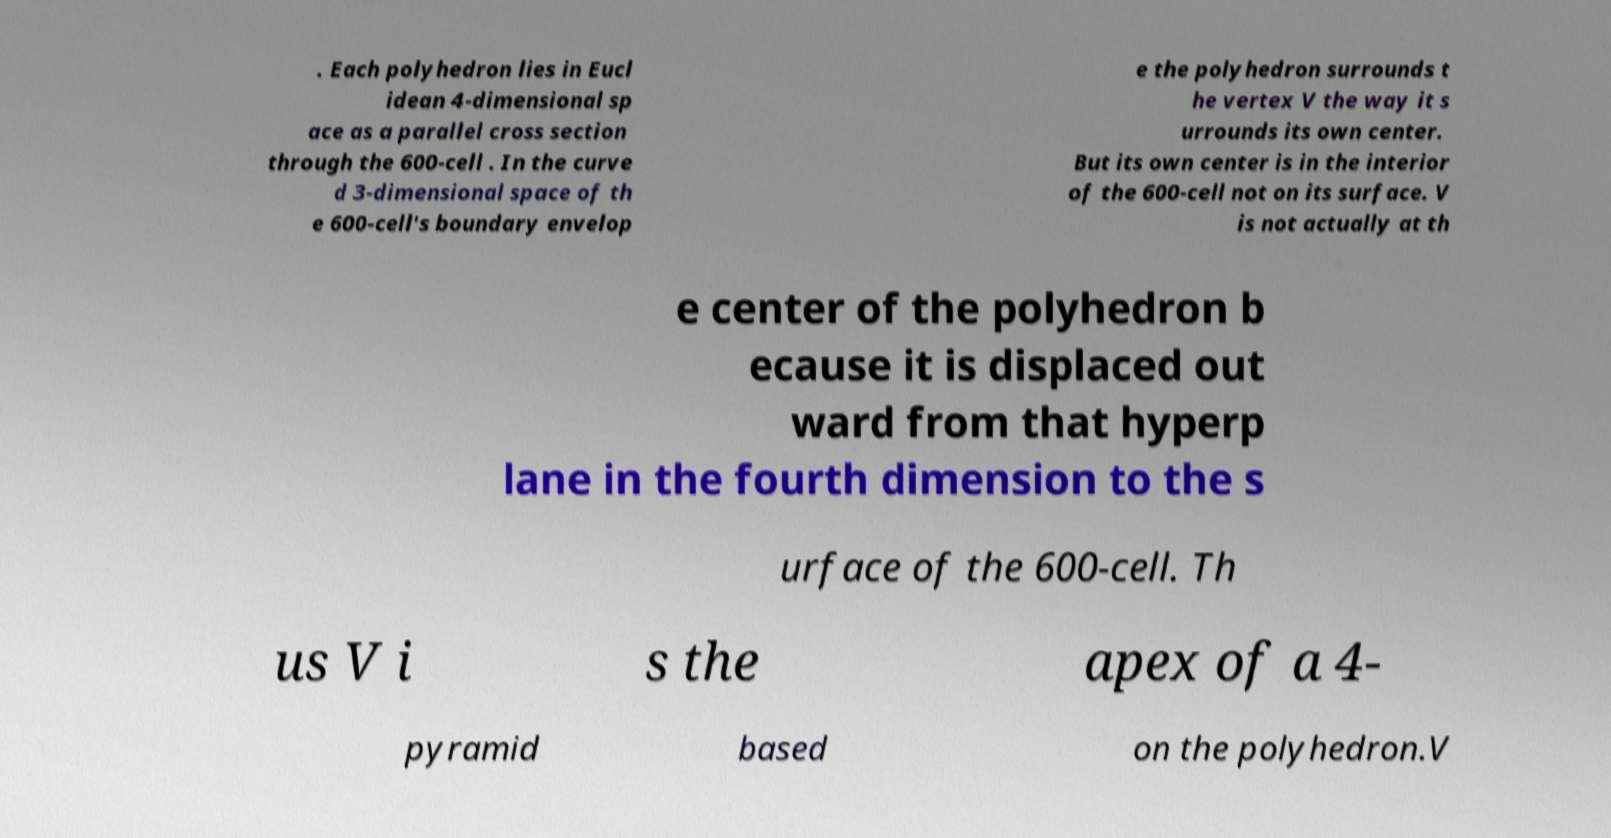Could you extract and type out the text from this image? . Each polyhedron lies in Eucl idean 4-dimensional sp ace as a parallel cross section through the 600-cell . In the curve d 3-dimensional space of th e 600-cell's boundary envelop e the polyhedron surrounds t he vertex V the way it s urrounds its own center. But its own center is in the interior of the 600-cell not on its surface. V is not actually at th e center of the polyhedron b ecause it is displaced out ward from that hyperp lane in the fourth dimension to the s urface of the 600-cell. Th us V i s the apex of a 4- pyramid based on the polyhedron.V 